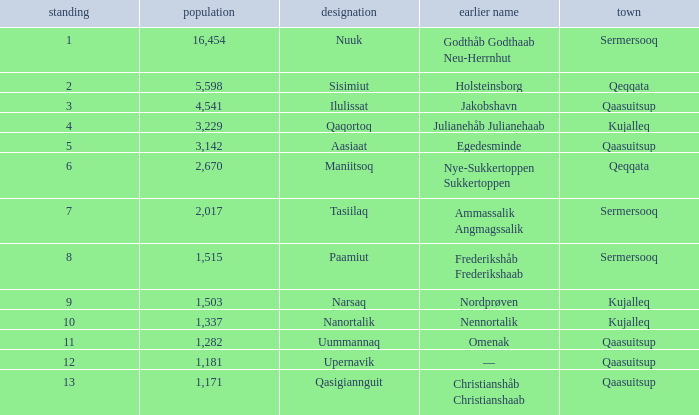Who has a former name of nordprøven? Narsaq. 